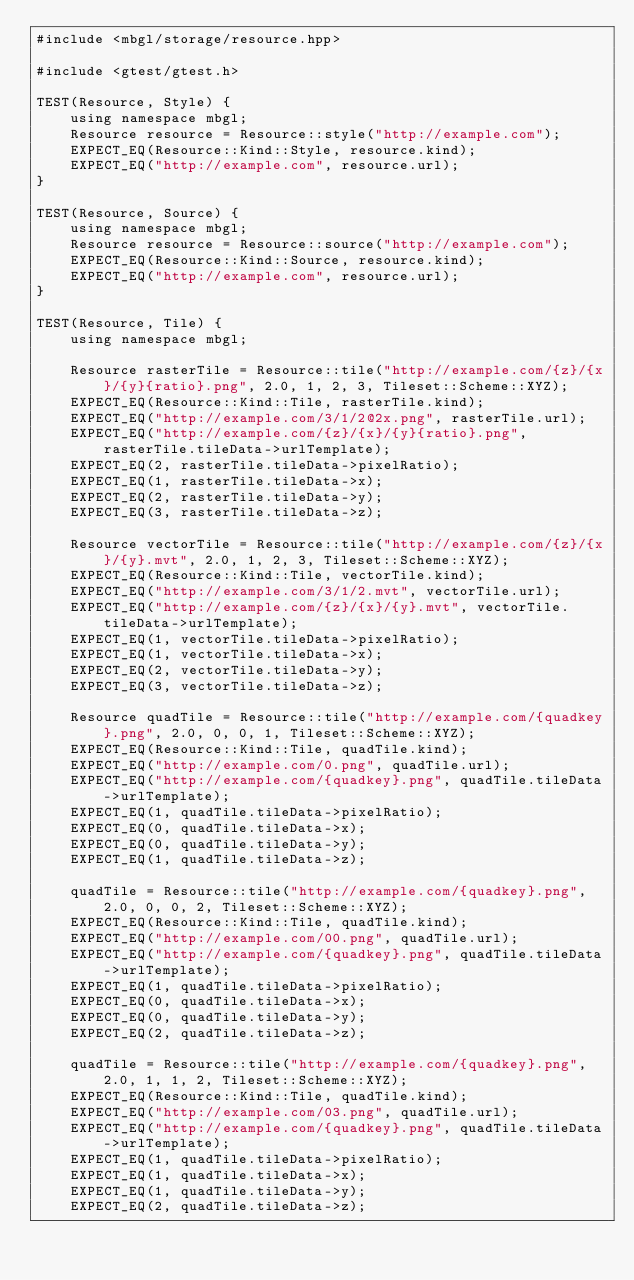<code> <loc_0><loc_0><loc_500><loc_500><_C++_>#include <mbgl/storage/resource.hpp>

#include <gtest/gtest.h>

TEST(Resource, Style) {
    using namespace mbgl;
    Resource resource = Resource::style("http://example.com");
    EXPECT_EQ(Resource::Kind::Style, resource.kind);
    EXPECT_EQ("http://example.com", resource.url);
}

TEST(Resource, Source) {
    using namespace mbgl;
    Resource resource = Resource::source("http://example.com");
    EXPECT_EQ(Resource::Kind::Source, resource.kind);
    EXPECT_EQ("http://example.com", resource.url);
}

TEST(Resource, Tile) {
    using namespace mbgl;

    Resource rasterTile = Resource::tile("http://example.com/{z}/{x}/{y}{ratio}.png", 2.0, 1, 2, 3, Tileset::Scheme::XYZ);
    EXPECT_EQ(Resource::Kind::Tile, rasterTile.kind);
    EXPECT_EQ("http://example.com/3/1/2@2x.png", rasterTile.url);
    EXPECT_EQ("http://example.com/{z}/{x}/{y}{ratio}.png", rasterTile.tileData->urlTemplate);
    EXPECT_EQ(2, rasterTile.tileData->pixelRatio);
    EXPECT_EQ(1, rasterTile.tileData->x);
    EXPECT_EQ(2, rasterTile.tileData->y);
    EXPECT_EQ(3, rasterTile.tileData->z);

    Resource vectorTile = Resource::tile("http://example.com/{z}/{x}/{y}.mvt", 2.0, 1, 2, 3, Tileset::Scheme::XYZ);
    EXPECT_EQ(Resource::Kind::Tile, vectorTile.kind);
    EXPECT_EQ("http://example.com/3/1/2.mvt", vectorTile.url);
    EXPECT_EQ("http://example.com/{z}/{x}/{y}.mvt", vectorTile.tileData->urlTemplate);
    EXPECT_EQ(1, vectorTile.tileData->pixelRatio);
    EXPECT_EQ(1, vectorTile.tileData->x);
    EXPECT_EQ(2, vectorTile.tileData->y);
    EXPECT_EQ(3, vectorTile.tileData->z);

    Resource quadTile = Resource::tile("http://example.com/{quadkey}.png", 2.0, 0, 0, 1, Tileset::Scheme::XYZ);
    EXPECT_EQ(Resource::Kind::Tile, quadTile.kind);
    EXPECT_EQ("http://example.com/0.png", quadTile.url);
    EXPECT_EQ("http://example.com/{quadkey}.png", quadTile.tileData->urlTemplate);
    EXPECT_EQ(1, quadTile.tileData->pixelRatio);
    EXPECT_EQ(0, quadTile.tileData->x);
    EXPECT_EQ(0, quadTile.tileData->y);
    EXPECT_EQ(1, quadTile.tileData->z);

    quadTile = Resource::tile("http://example.com/{quadkey}.png", 2.0, 0, 0, 2, Tileset::Scheme::XYZ);
    EXPECT_EQ(Resource::Kind::Tile, quadTile.kind);
    EXPECT_EQ("http://example.com/00.png", quadTile.url);
    EXPECT_EQ("http://example.com/{quadkey}.png", quadTile.tileData->urlTemplate);
    EXPECT_EQ(1, quadTile.tileData->pixelRatio);
    EXPECT_EQ(0, quadTile.tileData->x);
    EXPECT_EQ(0, quadTile.tileData->y);
    EXPECT_EQ(2, quadTile.tileData->z);

    quadTile = Resource::tile("http://example.com/{quadkey}.png", 2.0, 1, 1, 2, Tileset::Scheme::XYZ);
    EXPECT_EQ(Resource::Kind::Tile, quadTile.kind);
    EXPECT_EQ("http://example.com/03.png", quadTile.url);
    EXPECT_EQ("http://example.com/{quadkey}.png", quadTile.tileData->urlTemplate);
    EXPECT_EQ(1, quadTile.tileData->pixelRatio);
    EXPECT_EQ(1, quadTile.tileData->x);
    EXPECT_EQ(1, quadTile.tileData->y);
    EXPECT_EQ(2, quadTile.tileData->z);
</code> 